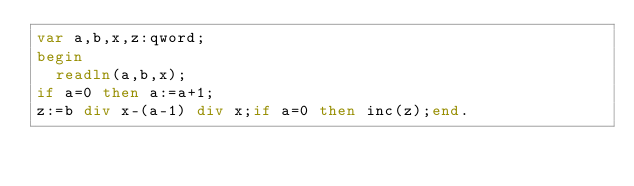Convert code to text. <code><loc_0><loc_0><loc_500><loc_500><_Pascal_>var a,b,x,z:qword;
begin
  readln(a,b,x);
if a=0 then a:=a+1;
z:=b div x-(a-1) div x;if a=0 then inc(z);end.</code> 